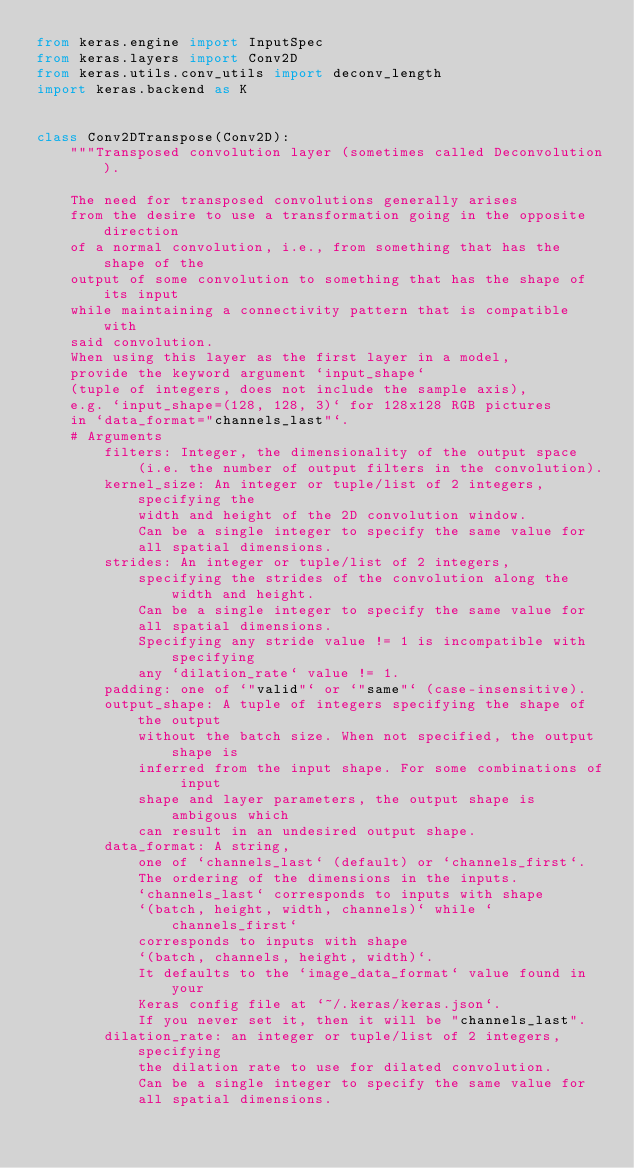<code> <loc_0><loc_0><loc_500><loc_500><_Python_>from keras.engine import InputSpec
from keras.layers import Conv2D
from keras.utils.conv_utils import deconv_length
import keras.backend as K


class Conv2DTranspose(Conv2D):
    """Transposed convolution layer (sometimes called Deconvolution).

    The need for transposed convolutions generally arises
    from the desire to use a transformation going in the opposite direction
    of a normal convolution, i.e., from something that has the shape of the
    output of some convolution to something that has the shape of its input
    while maintaining a connectivity pattern that is compatible with
    said convolution.
    When using this layer as the first layer in a model,
    provide the keyword argument `input_shape`
    (tuple of integers, does not include the sample axis),
    e.g. `input_shape=(128, 128, 3)` for 128x128 RGB pictures
    in `data_format="channels_last"`.
    # Arguments
        filters: Integer, the dimensionality of the output space
            (i.e. the number of output filters in the convolution).
        kernel_size: An integer or tuple/list of 2 integers, specifying the
            width and height of the 2D convolution window.
            Can be a single integer to specify the same value for
            all spatial dimensions.
        strides: An integer or tuple/list of 2 integers,
            specifying the strides of the convolution along the width and height.
            Can be a single integer to specify the same value for
            all spatial dimensions.
            Specifying any stride value != 1 is incompatible with specifying
            any `dilation_rate` value != 1.
        padding: one of `"valid"` or `"same"` (case-insensitive).
        output_shape: A tuple of integers specifying the shape of the output
            without the batch size. When not specified, the output shape is
            inferred from the input shape. For some combinations of input
            shape and layer parameters, the output shape is ambigous which
            can result in an undesired output shape.
        data_format: A string,
            one of `channels_last` (default) or `channels_first`.
            The ordering of the dimensions in the inputs.
            `channels_last` corresponds to inputs with shape
            `(batch, height, width, channels)` while `channels_first`
            corresponds to inputs with shape
            `(batch, channels, height, width)`.
            It defaults to the `image_data_format` value found in your
            Keras config file at `~/.keras/keras.json`.
            If you never set it, then it will be "channels_last".
        dilation_rate: an integer or tuple/list of 2 integers, specifying
            the dilation rate to use for dilated convolution.
            Can be a single integer to specify the same value for
            all spatial dimensions.</code> 